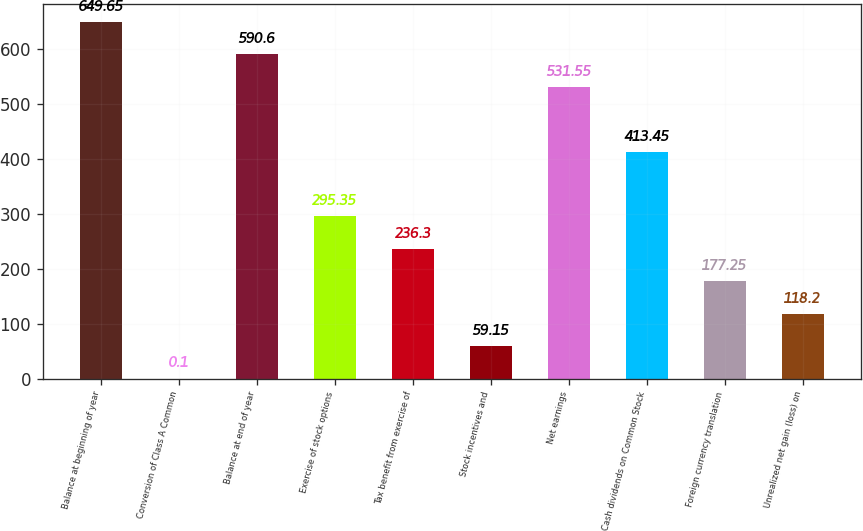<chart> <loc_0><loc_0><loc_500><loc_500><bar_chart><fcel>Balance at beginning of year<fcel>Conversion of Class A Common<fcel>Balance at end of year<fcel>Exercise of stock options<fcel>Tax benefit from exercise of<fcel>Stock incentives and<fcel>Net earnings<fcel>Cash dividends on Common Stock<fcel>Foreign currency translation<fcel>Unrealized net gain (loss) on<nl><fcel>649.65<fcel>0.1<fcel>590.6<fcel>295.35<fcel>236.3<fcel>59.15<fcel>531.55<fcel>413.45<fcel>177.25<fcel>118.2<nl></chart> 